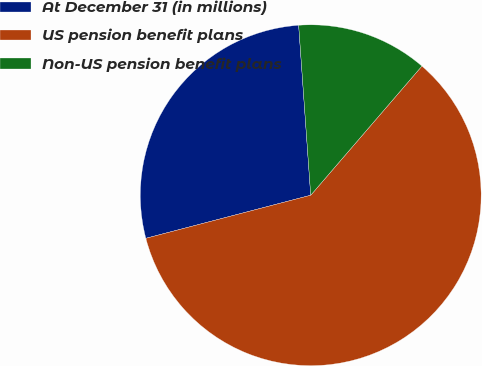Convert chart to OTSL. <chart><loc_0><loc_0><loc_500><loc_500><pie_chart><fcel>At December 31 (in millions)<fcel>US pension benefit plans<fcel>Non-US pension benefit plans<nl><fcel>27.94%<fcel>59.62%<fcel>12.44%<nl></chart> 